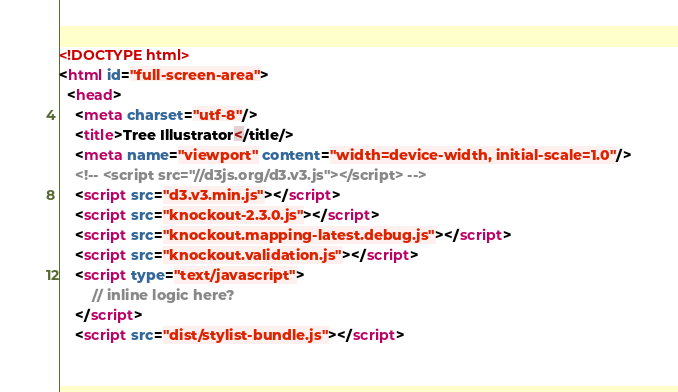<code> <loc_0><loc_0><loc_500><loc_500><_HTML_><!DOCTYPE html>
<html id="full-screen-area">
  <head>
    <meta charset="utf-8"/>
    <title>Tree Illustrator</title/>
    <meta name="viewport" content="width=device-width, initial-scale=1.0"/>
    <!-- <script src="//d3js.org/d3.v3.js"></script> -->
    <script src="d3.v3.min.js"></script>
    <script src="knockout-2.3.0.js"></script>
    <script src="knockout.mapping-latest.debug.js"></script>
    <script src="knockout.validation.js"></script>
    <script type="text/javascript">
        // inline logic here?
    </script>
    <script src="dist/stylist-bundle.js"></script></code> 